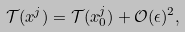<formula> <loc_0><loc_0><loc_500><loc_500>\mathcal { T } ( x ^ { j } ) = \mathcal { T } ( x ^ { j } _ { 0 } ) + \mathcal { O } ( \epsilon ) ^ { 2 } ,</formula> 